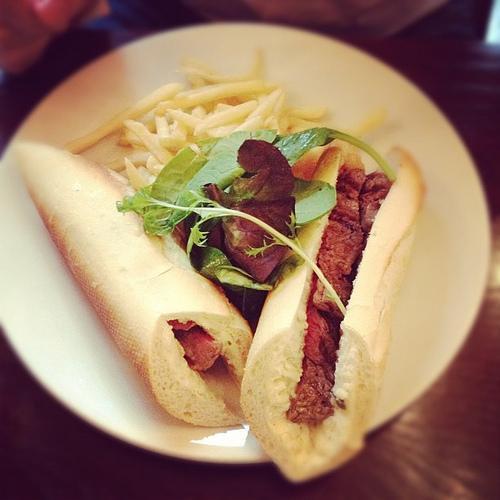How many slices of sandwich on the plate?
Give a very brief answer. 2. 